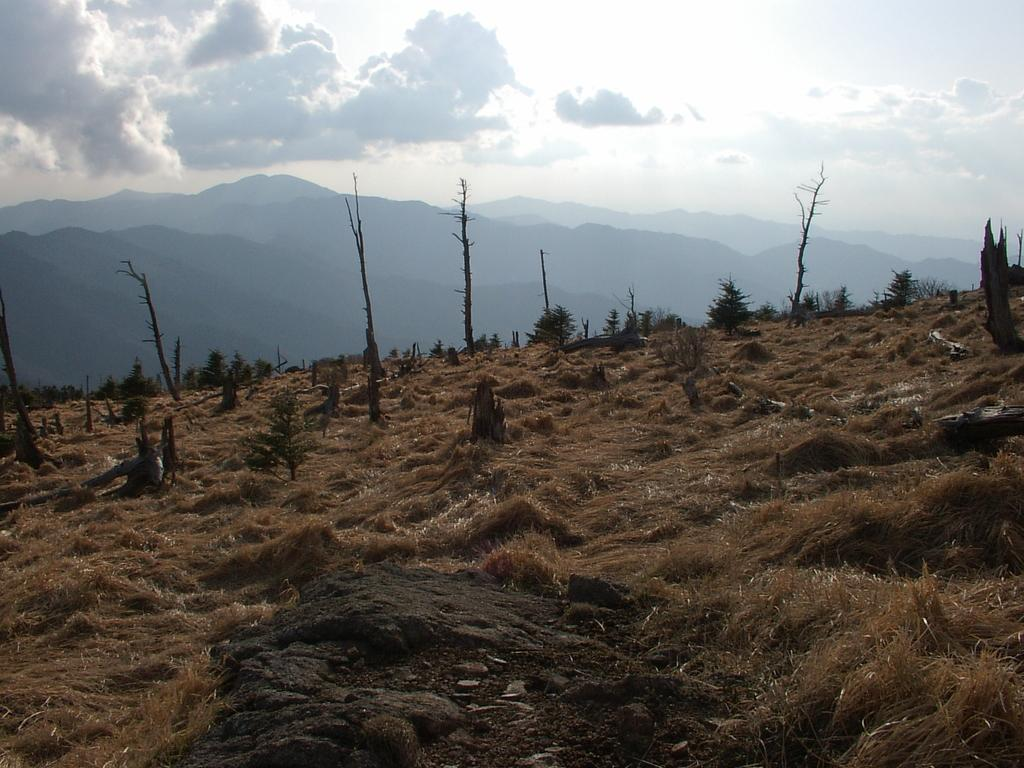What type of vegetation can be seen in the image? There are trees in the image. What geographical features are present in the image? There are hills in the image. What can be seen in the background of the image? The sky is visible in the background of the image. What type of authority is depicted in the image? There is no authority figure present in the image; it features trees, hills, and the sky. What type of prose can be read in the image? There is no text or prose present in the image; it is a visual representation of trees, hills, and the sky. 